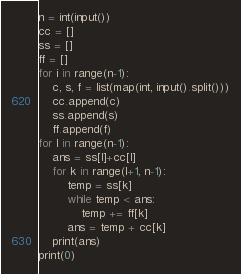Convert code to text. <code><loc_0><loc_0><loc_500><loc_500><_Python_>n = int(input())
cc = []
ss = []
ff = []
for i in range(n-1):
    c, s, f = list(map(int, input().split()))
    cc.append(c)
    ss.append(s)
    ff.append(f)
for l in range(n-1):
    ans = ss[l]+cc[l]
    for k in range(l+1, n-1):
        temp = ss[k]
        while temp < ans:
            temp += ff[k]
        ans = temp + cc[k]
    print(ans)
print(0)

</code> 